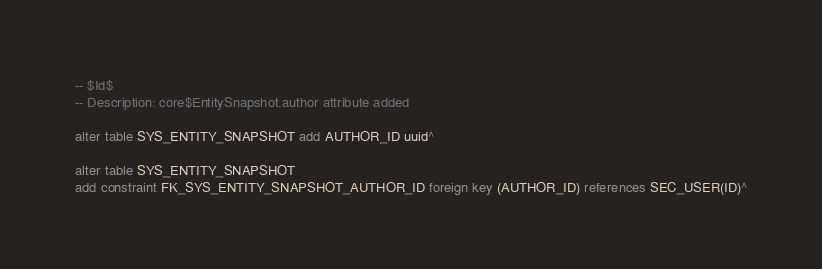Convert code to text. <code><loc_0><loc_0><loc_500><loc_500><_SQL_>-- $Id$
-- Description: core$EntitySnapshot.author attribute added

alter table SYS_ENTITY_SNAPSHOT add AUTHOR_ID uuid^

alter table SYS_ENTITY_SNAPSHOT
add constraint FK_SYS_ENTITY_SNAPSHOT_AUTHOR_ID foreign key (AUTHOR_ID) references SEC_USER(ID)^</code> 